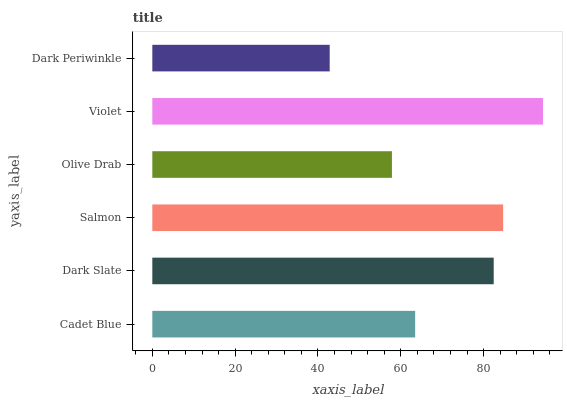Is Dark Periwinkle the minimum?
Answer yes or no. Yes. Is Violet the maximum?
Answer yes or no. Yes. Is Dark Slate the minimum?
Answer yes or no. No. Is Dark Slate the maximum?
Answer yes or no. No. Is Dark Slate greater than Cadet Blue?
Answer yes or no. Yes. Is Cadet Blue less than Dark Slate?
Answer yes or no. Yes. Is Cadet Blue greater than Dark Slate?
Answer yes or no. No. Is Dark Slate less than Cadet Blue?
Answer yes or no. No. Is Dark Slate the high median?
Answer yes or no. Yes. Is Cadet Blue the low median?
Answer yes or no. Yes. Is Dark Periwinkle the high median?
Answer yes or no. No. Is Dark Slate the low median?
Answer yes or no. No. 